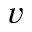Convert formula to latex. <formula><loc_0><loc_0><loc_500><loc_500>v</formula> 